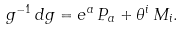<formula> <loc_0><loc_0><loc_500><loc_500>g ^ { - 1 } \, d g = e ^ { a } \, P _ { a } + \theta ^ { i } \, M _ { i } .</formula> 